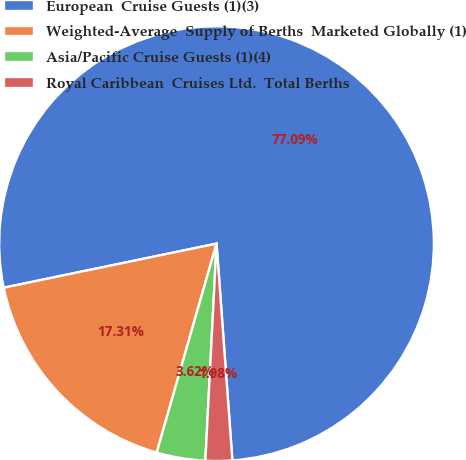Convert chart to OTSL. <chart><loc_0><loc_0><loc_500><loc_500><pie_chart><fcel>European  Cruise Guests (1)(3)<fcel>Weighted-Average  Supply of Berths  Marketed Globally (1)<fcel>Asia/Pacific Cruise Guests (1)(4)<fcel>Royal Caribbean  Cruises Ltd.  Total Berths<nl><fcel>77.09%<fcel>17.31%<fcel>3.62%<fcel>1.98%<nl></chart> 